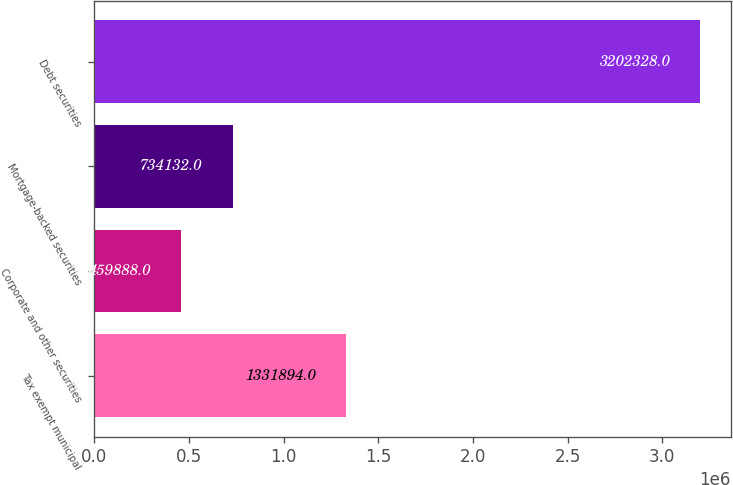Convert chart. <chart><loc_0><loc_0><loc_500><loc_500><bar_chart><fcel>Tax exempt municipal<fcel>Corporate and other securities<fcel>Mortgage-backed securities<fcel>Debt securities<nl><fcel>1.33189e+06<fcel>459888<fcel>734132<fcel>3.20233e+06<nl></chart> 